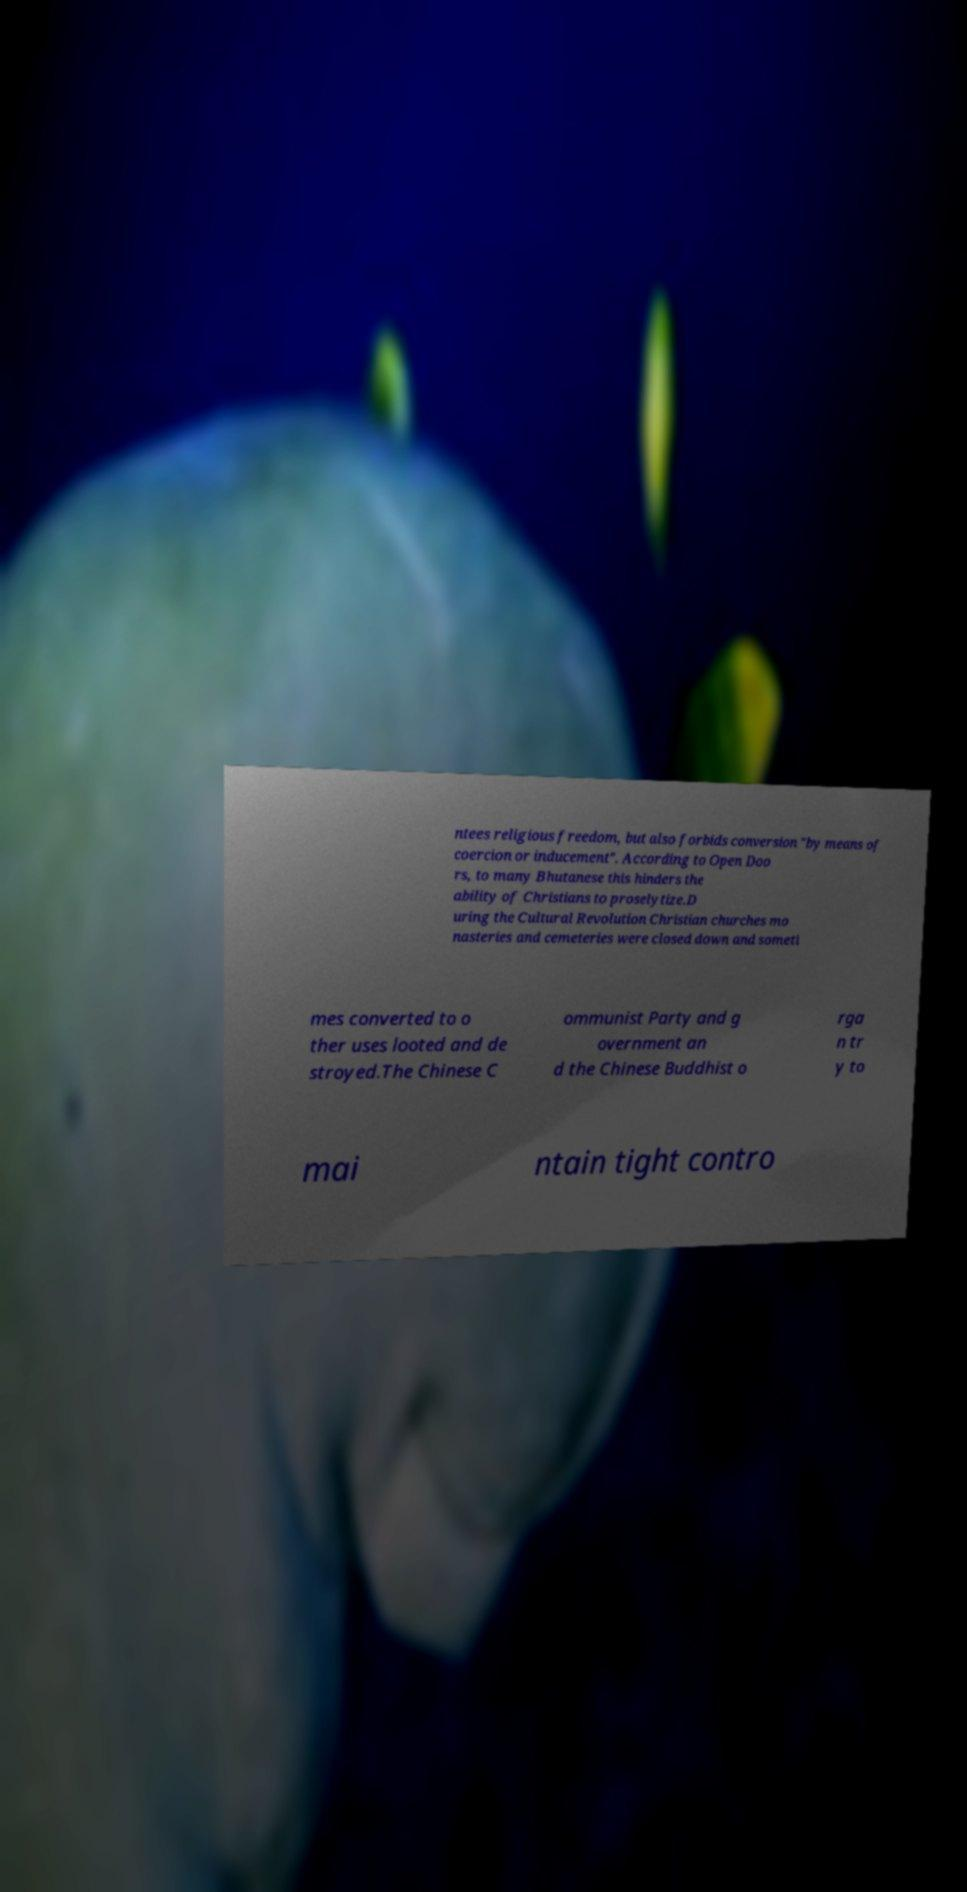Could you extract and type out the text from this image? ntees religious freedom, but also forbids conversion "by means of coercion or inducement". According to Open Doo rs, to many Bhutanese this hinders the ability of Christians to proselytize.D uring the Cultural Revolution Christian churches mo nasteries and cemeteries were closed down and someti mes converted to o ther uses looted and de stroyed.The Chinese C ommunist Party and g overnment an d the Chinese Buddhist o rga n tr y to mai ntain tight contro 